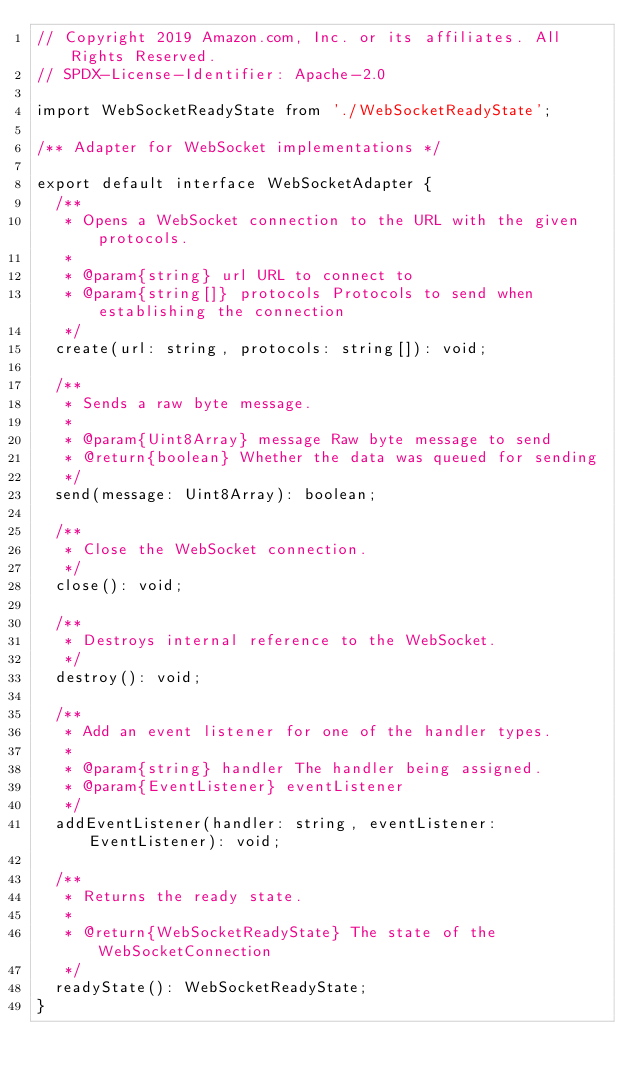<code> <loc_0><loc_0><loc_500><loc_500><_TypeScript_>// Copyright 2019 Amazon.com, Inc. or its affiliates. All Rights Reserved.
// SPDX-License-Identifier: Apache-2.0

import WebSocketReadyState from './WebSocketReadyState';

/** Adapter for WebSocket implementations */

export default interface WebSocketAdapter {
  /**
   * Opens a WebSocket connection to the URL with the given protocols.
   *
   * @param{string} url URL to connect to
   * @param{string[]} protocols Protocols to send when establishing the connection
   */
  create(url: string, protocols: string[]): void;

  /**
   * Sends a raw byte message.
   *
   * @param{Uint8Array} message Raw byte message to send
   * @return{boolean} Whether the data was queued for sending
   */
  send(message: Uint8Array): boolean;

  /**
   * Close the WebSocket connection.
   */
  close(): void;

  /**
   * Destroys internal reference to the WebSocket.
   */
  destroy(): void;

  /**
   * Add an event listener for one of the handler types.
   *
   * @param{string} handler The handler being assigned.
   * @param{EventListener} eventListener
   */
  addEventListener(handler: string, eventListener: EventListener): void;

  /**
   * Returns the ready state.
   *
   * @return{WebSocketReadyState} The state of the WebSocketConnection
   */
  readyState(): WebSocketReadyState;
}
</code> 